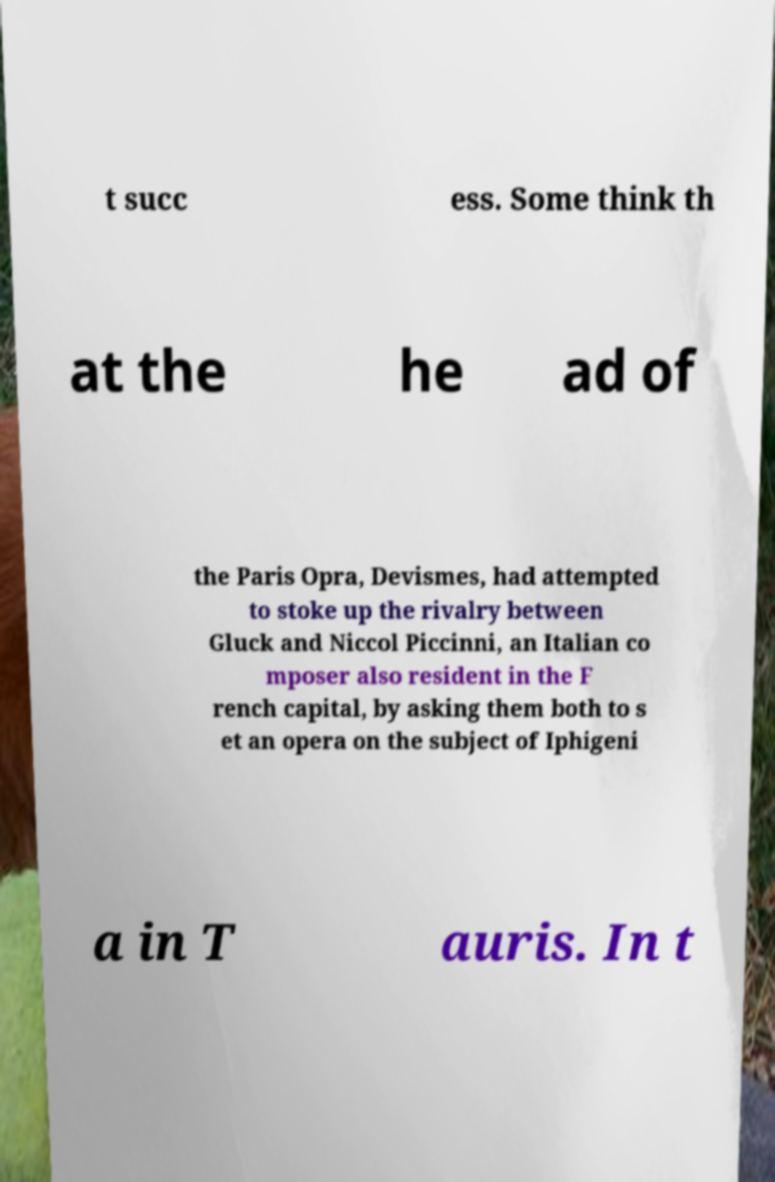Could you assist in decoding the text presented in this image and type it out clearly? t succ ess. Some think th at the he ad of the Paris Opra, Devismes, had attempted to stoke up the rivalry between Gluck and Niccol Piccinni, an Italian co mposer also resident in the F rench capital, by asking them both to s et an opera on the subject of Iphigeni a in T auris. In t 